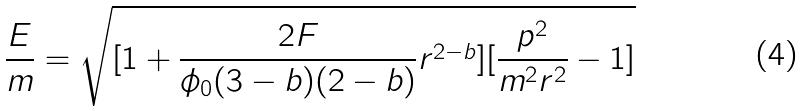Convert formula to latex. <formula><loc_0><loc_0><loc_500><loc_500>\frac { E } { m } = \sqrt { [ 1 + \frac { 2 F } { \phi _ { 0 } ( 3 - b ) ( 2 - b ) } r ^ { 2 - b } ] [ \frac { p ^ { 2 } } { m ^ { 2 } r ^ { 2 } } - 1 ] }</formula> 